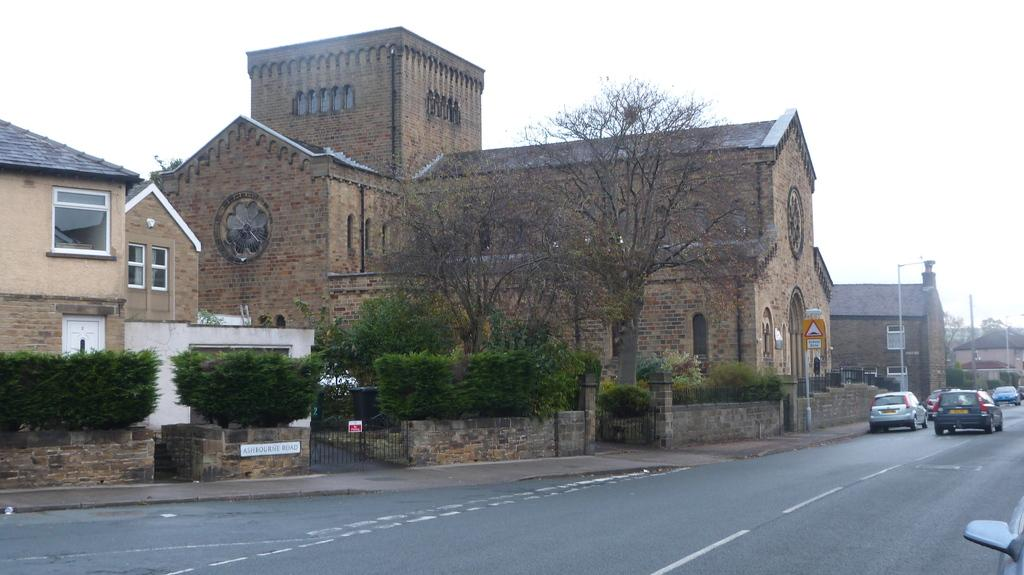What types of structures can be seen in the image? There are buildings, walls, and gates in the image. What type of vegetation is present in the image? There are trees and plants in the image. What else can be seen on the ground in the image? There are vehicles on the road in the image. What else can be seen in the image besides the structures and vegetation? There are boards and poles in the image. What is visible in the background of the image? The sky is visible in the background of the image. Can you tell me how much jam is on the father's toast in the image? There is no father or toast with jam present in the image. How many horses are visible in the image? There are no horses present in the image. 